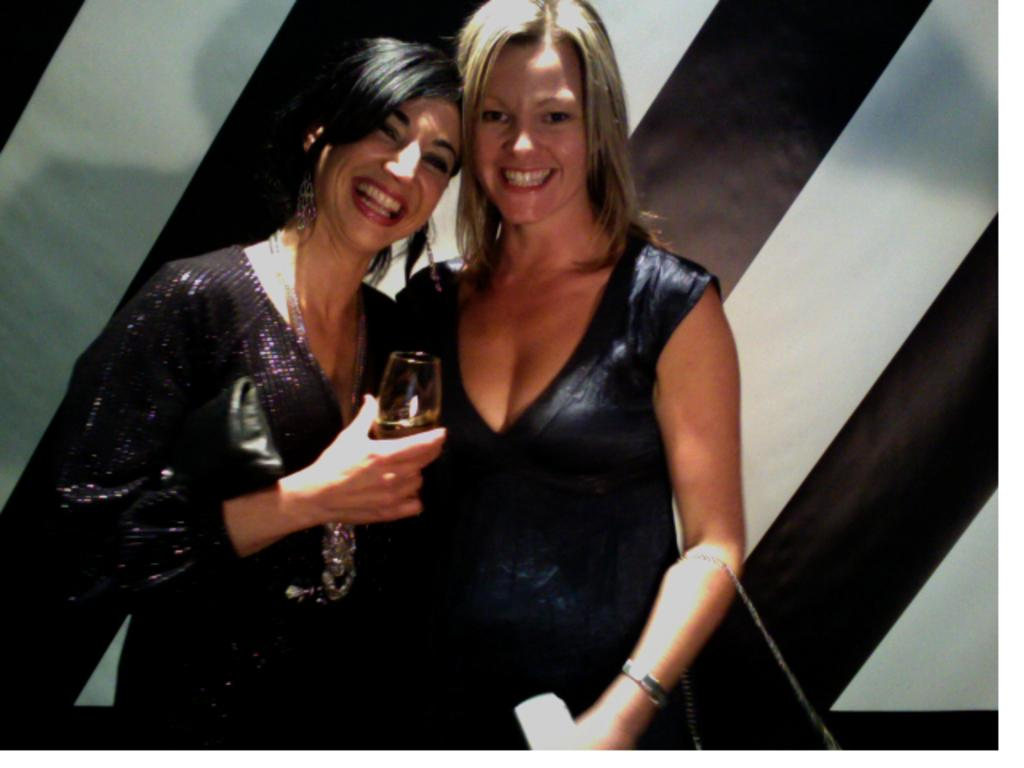How many people are in the image? There are two women in the image. What are the women doing in the image? The women are standing and smiling. What are the women holding in the image? The women are holding a glass. What can be seen in the background of the image? There is a wall in the background of the image. What type of shoe can be seen on the wall in the image? There is no shoe present on the wall in the image. How many pizzas are the women eating in the image? There are no pizzas visible in the image; the women are holding a glass. 